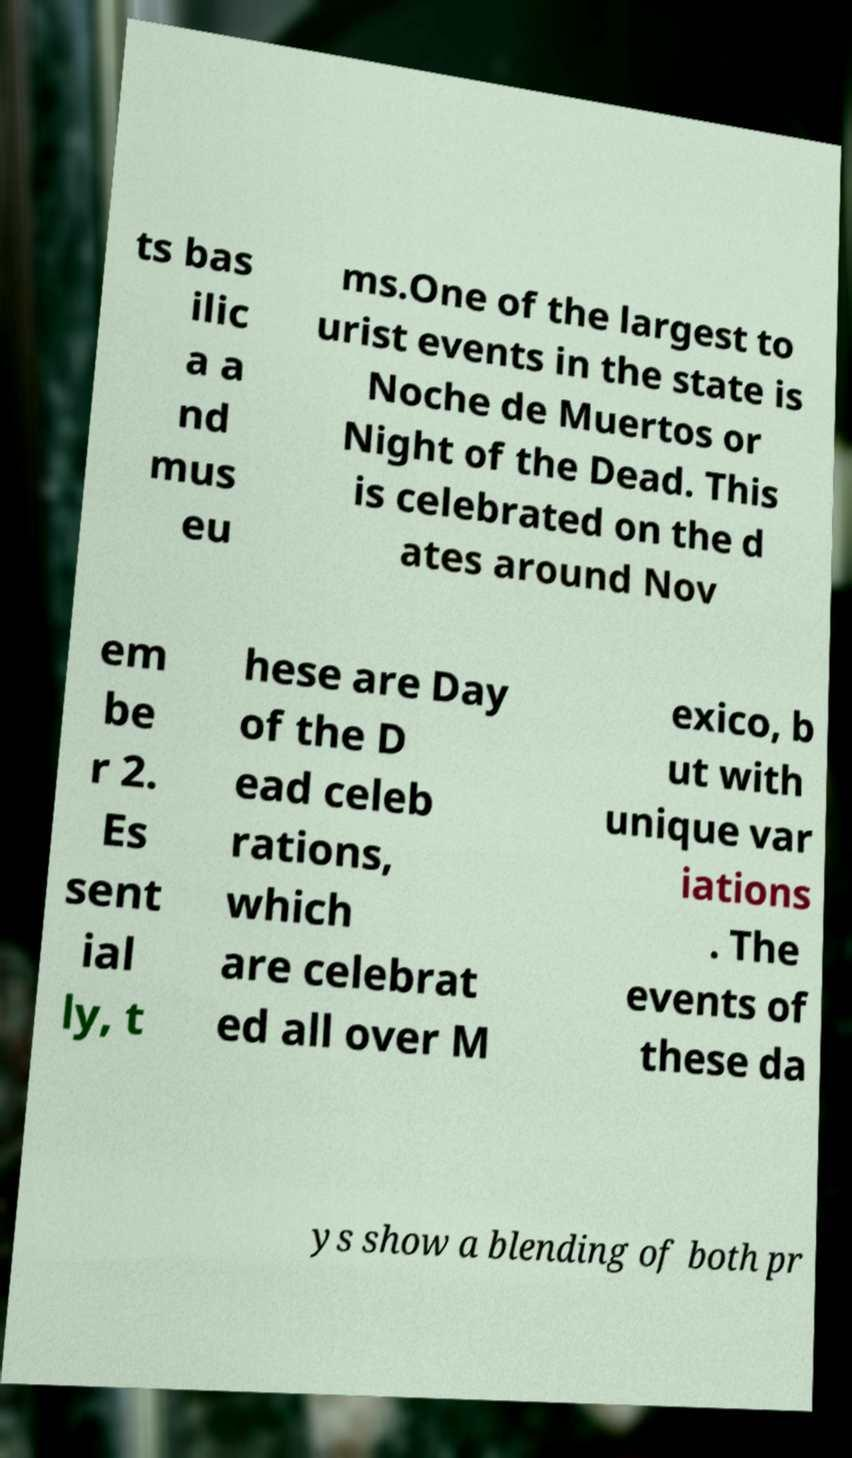There's text embedded in this image that I need extracted. Can you transcribe it verbatim? ts bas ilic a a nd mus eu ms.One of the largest to urist events in the state is Noche de Muertos or Night of the Dead. This is celebrated on the d ates around Nov em be r 2. Es sent ial ly, t hese are Day of the D ead celeb rations, which are celebrat ed all over M exico, b ut with unique var iations . The events of these da ys show a blending of both pr 